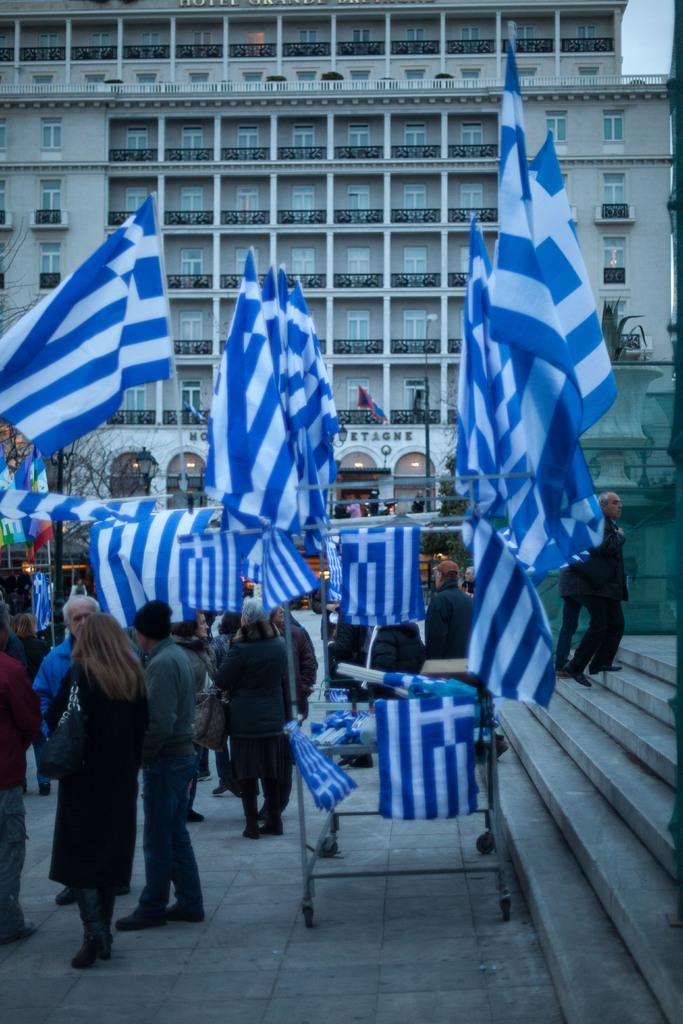How many people are in the image? There is a group of people in the image, but the exact number cannot be determined without more information. What can be seen in addition to the people in the image? There are flags in the image. What is visible in the background of the image? There is a building in the background of the image. What rate is being charged for the cloth in the image? There is no cloth or payment mentioned in the image, so it is not possible to determine a rate. 